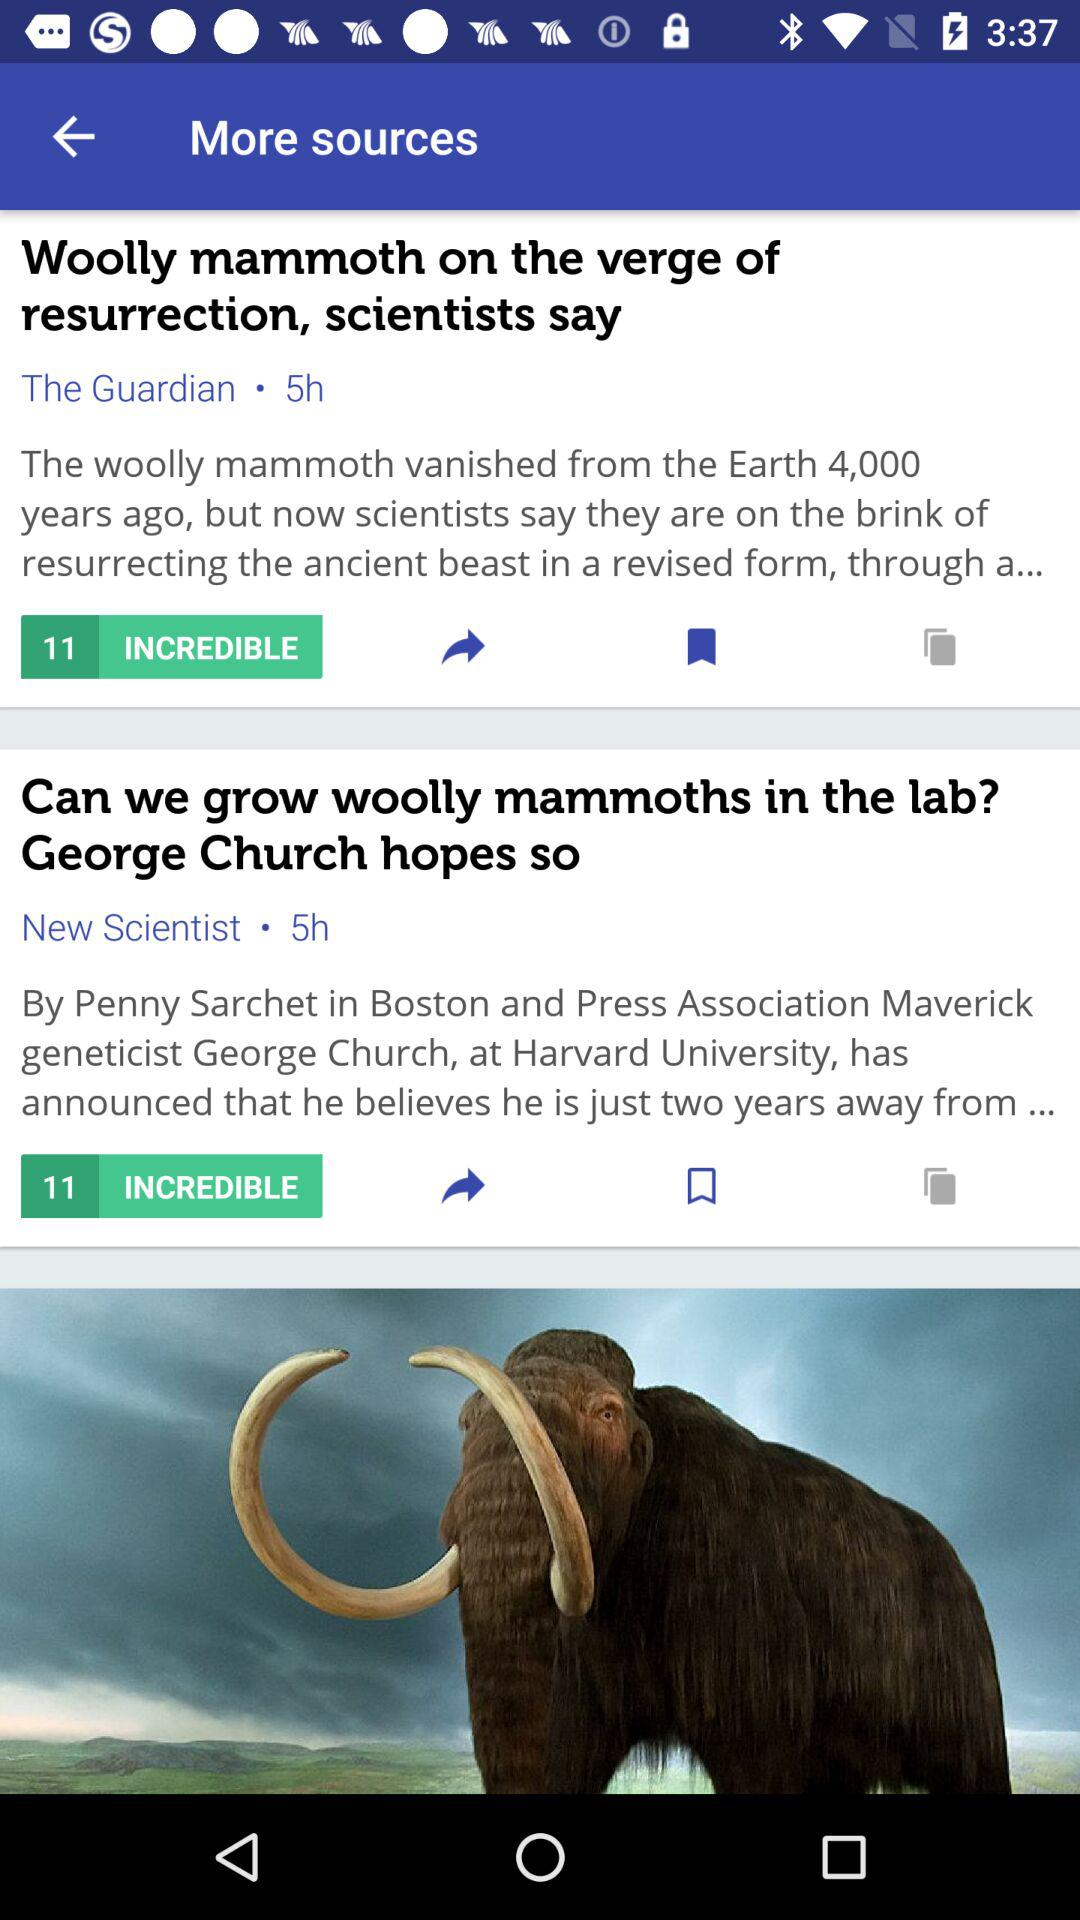How long ago was the "Wooly mammoth on the verge of resurrection, scientists say" uploaded? The post "Wooly mammoth on the verge of resurrection, scientists say" was uploaded 5 hours ago. 